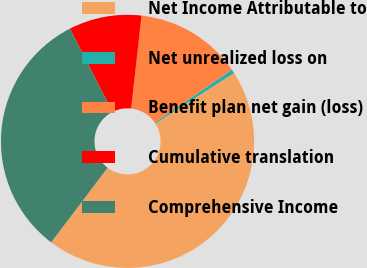Convert chart to OTSL. <chart><loc_0><loc_0><loc_500><loc_500><pie_chart><fcel>Net Income Attributable to<fcel>Net unrealized loss on<fcel>Benefit plan net gain (loss)<fcel>Cumulative translation<fcel>Comprehensive Income<nl><fcel>44.38%<fcel>0.5%<fcel>13.66%<fcel>9.28%<fcel>32.18%<nl></chart> 